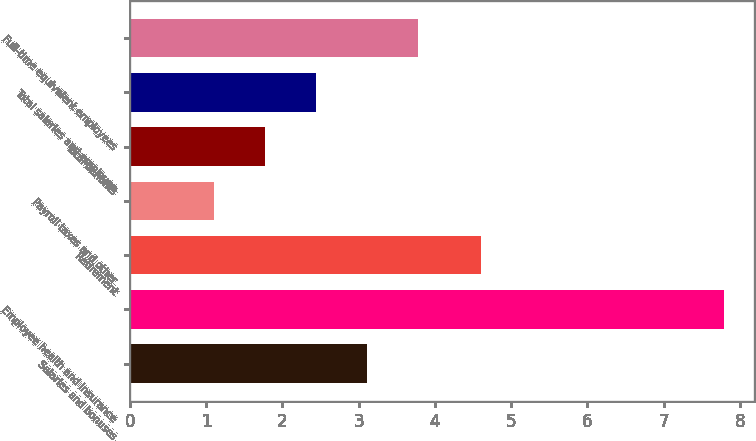Convert chart. <chart><loc_0><loc_0><loc_500><loc_500><bar_chart><fcel>Salaries and bonuses<fcel>Employee health and insurance<fcel>Retirement<fcel>Payroll taxes and other<fcel>Total benefits<fcel>Total salaries and employee<fcel>Full-time equivalent employees<nl><fcel>3.11<fcel>7.8<fcel>4.6<fcel>1.1<fcel>1.77<fcel>2.44<fcel>3.78<nl></chart> 